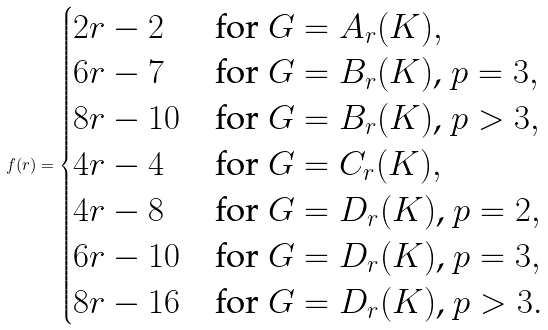<formula> <loc_0><loc_0><loc_500><loc_500>f ( r ) = \begin{cases} 2 r - 2 & \text {for $G=A_{r}(K)$} , \\ 6 r - 7 & \text {for $G=B_{r}(K)$, $p=3$} , \\ 8 r - 1 0 & \text {for $G=B_{r}(K)$, $p>3$} , \\ 4 r - 4 & \text {for $G=C_{r}(K)$} , \\ 4 r - 8 & \text {for $G=D_{r}(K)$, $p=2$} , \\ 6 r - 1 0 & \text {for $G=D_{r}(K)$, $p=3$} , \\ 8 r - 1 6 & \text {for $G=D_{r}(K)$, $p>3$} . \end{cases}</formula> 